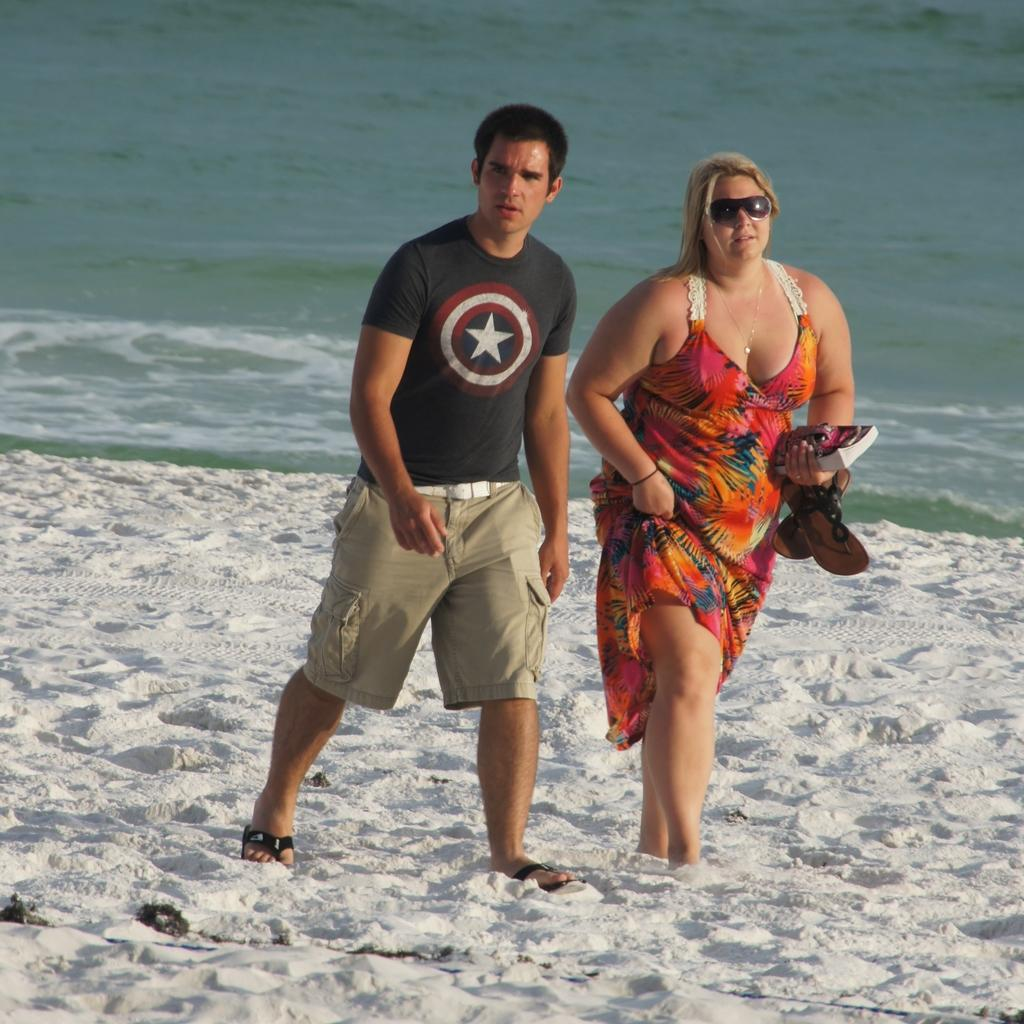How many people are in the image? There are two persons in the image. Can you describe the gender of the persons? One person is male, and the other is female. What are the male and female persons holding in the image? They are holding a book and sandals. What is visible in the background of the image? There is water visible behind the two persons. What type of jelly can be seen floating in the water behind the two persons? There is no jelly present in the image; only water is visible in the background. 